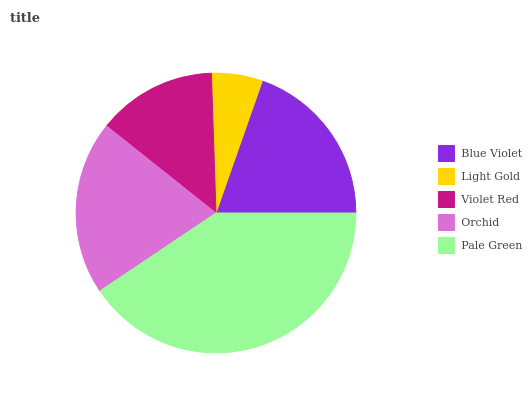Is Light Gold the minimum?
Answer yes or no. Yes. Is Pale Green the maximum?
Answer yes or no. Yes. Is Violet Red the minimum?
Answer yes or no. No. Is Violet Red the maximum?
Answer yes or no. No. Is Violet Red greater than Light Gold?
Answer yes or no. Yes. Is Light Gold less than Violet Red?
Answer yes or no. Yes. Is Light Gold greater than Violet Red?
Answer yes or no. No. Is Violet Red less than Light Gold?
Answer yes or no. No. Is Blue Violet the high median?
Answer yes or no. Yes. Is Blue Violet the low median?
Answer yes or no. Yes. Is Violet Red the high median?
Answer yes or no. No. Is Pale Green the low median?
Answer yes or no. No. 